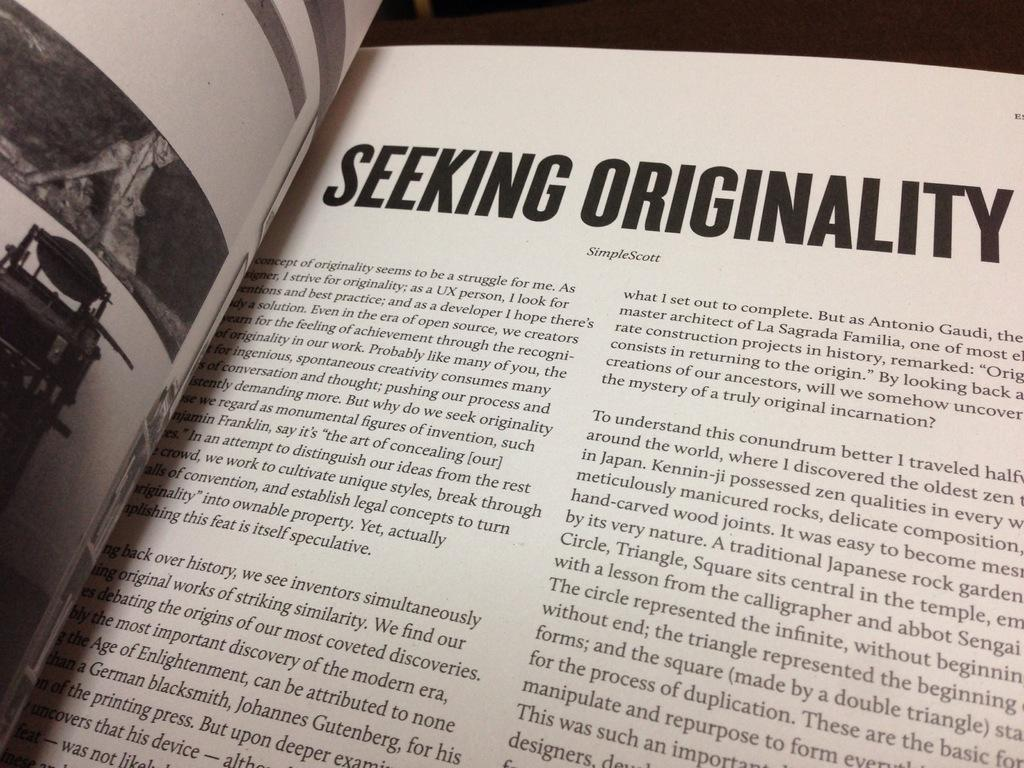<image>
Create a compact narrative representing the image presented. A book is open to a page titled "Seeking Originality". 